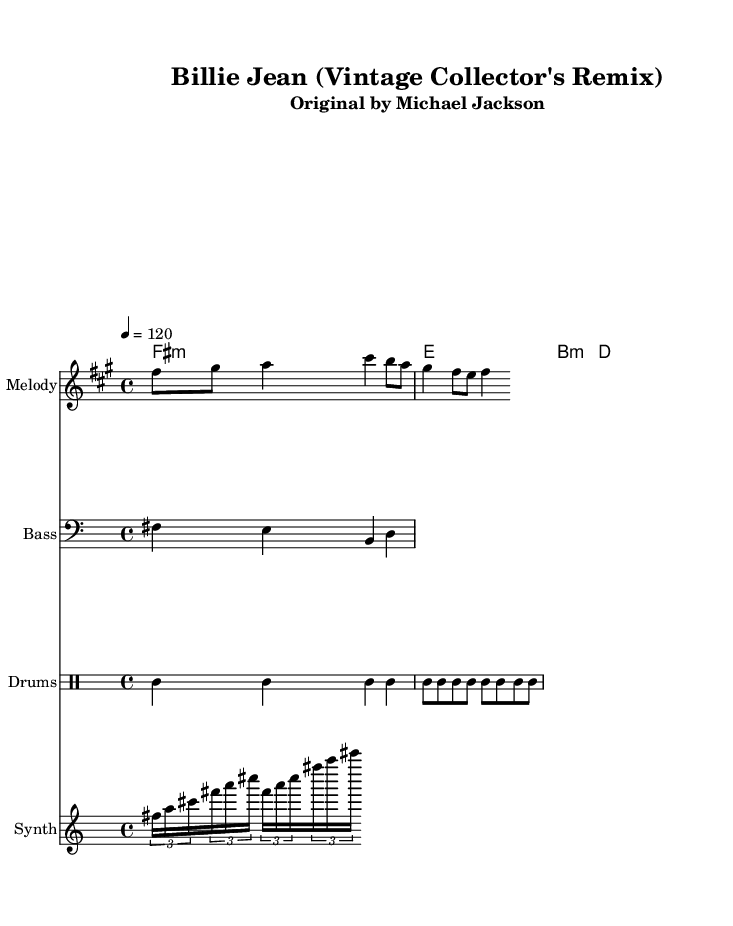What is the key signature of this music? The key signature is indicated by the sharp signs in the music, specifically showing that F is sharp. This corresponds to the key of F# minor, which contains three sharps: F#, C#, and G#.
Answer: F# minor What is the time signature of this music? The time signature is indicated at the beginning of the sheet music, shown as 4/4. This signifies that there are four beats in each measure and a quarter note gets one beat.
Answer: 4/4 What is the tempo marking for this piece? The tempo marking is provided in the sheet music as "4 = 120", indicating that the quarter note should be played at a speed of 120 beats per minute.
Answer: 120 How many measures are in the melody part? The melody contains eight individual segments or measures as indicated by the structure of the notes and the slashes that denote the end of each measure.
Answer: 4 What type of drums are used in this piece? The types of drums used are indicated in the percussion section, which includes the bass drum (bd), snare drum (sn), and hi-hat (hh). These are standard elements in dance music for providing rhythm.
Answer: Bass drum, snare drum, hi-hat What is the rhythmic pattern of the synth section? The rhythmic pattern of the synth section is achieved through the use of tuplets, specifically identified by the triplet indications in the notation. This suggests a syncopated, flowing rhythm suitable for dance music.
Answer: Triplet Which artist originally performed the song "Billie Jean"? The title header of the sheet music clearly states that the original artist of "Billie Jean" is Michael Jackson, known for his influential contributions to dance music.
Answer: Michael Jackson 